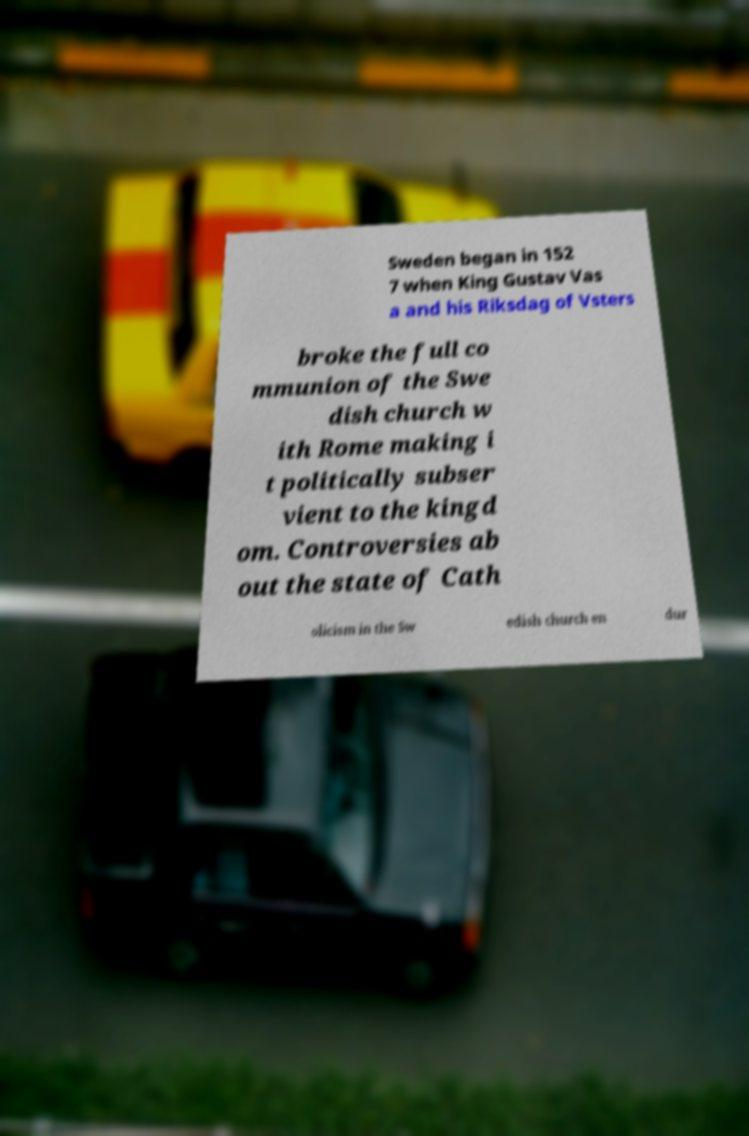Could you extract and type out the text from this image? Sweden began in 152 7 when King Gustav Vas a and his Riksdag of Vsters broke the full co mmunion of the Swe dish church w ith Rome making i t politically subser vient to the kingd om. Controversies ab out the state of Cath olicism in the Sw edish church en dur 